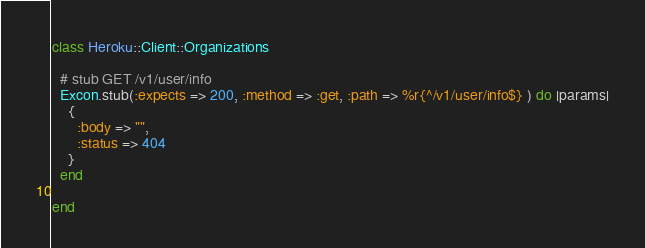Convert code to text. <code><loc_0><loc_0><loc_500><loc_500><_Ruby_>class Heroku::Client::Organizations

  # stub GET /v1/user/info
  Excon.stub(:expects => 200, :method => :get, :path => %r{^/v1/user/info$} ) do |params|
    {
      :body => "",
      :status => 404
    }
  end

end</code> 